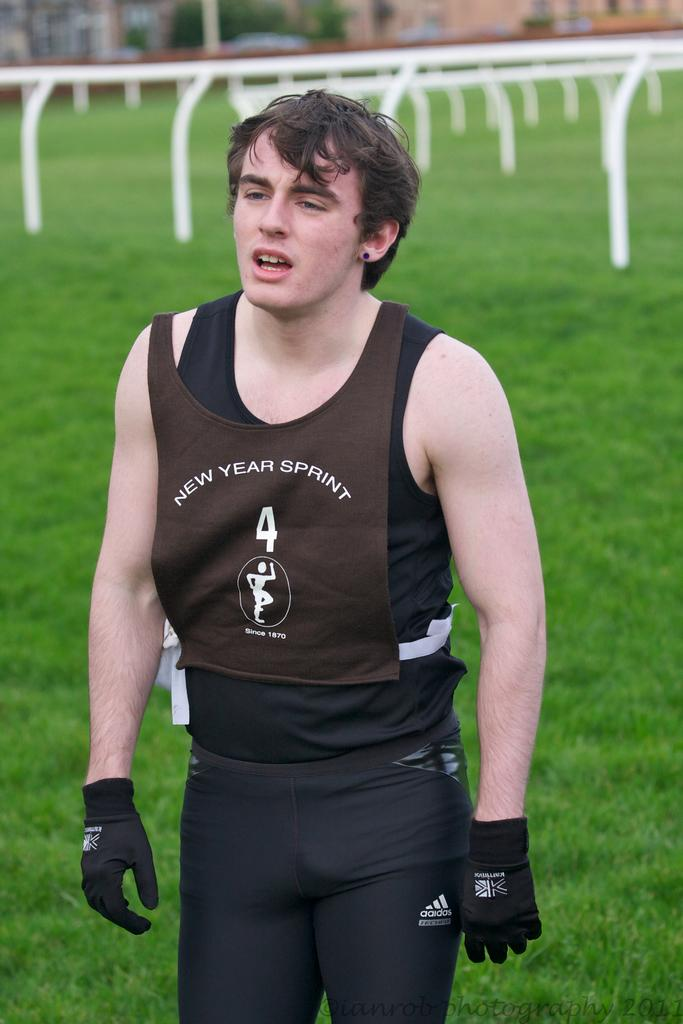Who is present in the image? There is a man in the image. What is the man wearing? The man is wearing a black dress. What can be seen in the background of the image? There are buildings, trees, and a metal rod in the background of the image. What type of vegetation is visible at the bottom of the image? There is grass visible at the bottom of the image. What type of corn can be seen growing in the image? There is no corn present in the image. What part of the brain is visible in the image? There is no brain present in the image. 